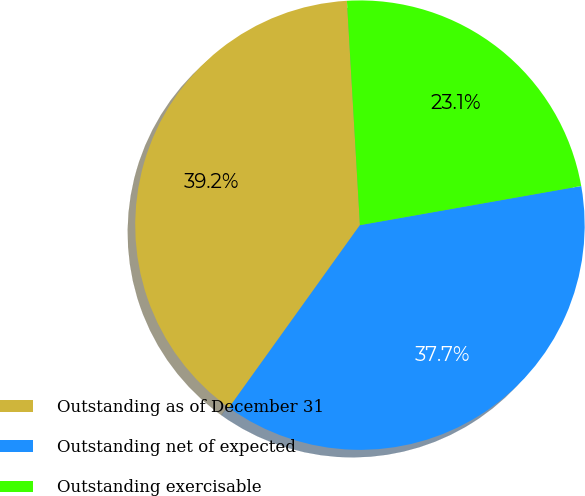<chart> <loc_0><loc_0><loc_500><loc_500><pie_chart><fcel>Outstanding as of December 31<fcel>Outstanding net of expected<fcel>Outstanding exercisable<nl><fcel>39.18%<fcel>37.69%<fcel>23.14%<nl></chart> 